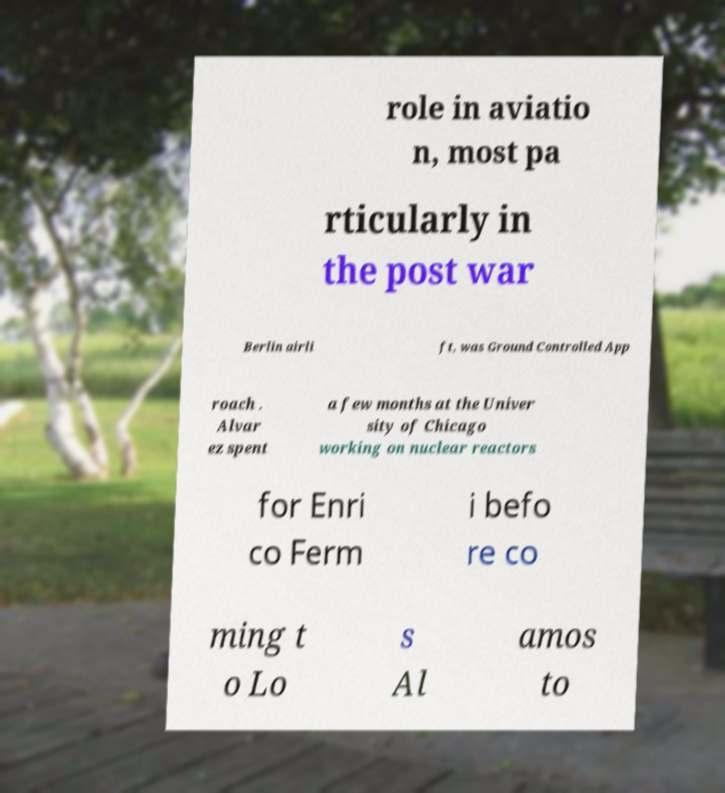There's text embedded in this image that I need extracted. Can you transcribe it verbatim? role in aviatio n, most pa rticularly in the post war Berlin airli ft, was Ground Controlled App roach . Alvar ez spent a few months at the Univer sity of Chicago working on nuclear reactors for Enri co Ferm i befo re co ming t o Lo s Al amos to 